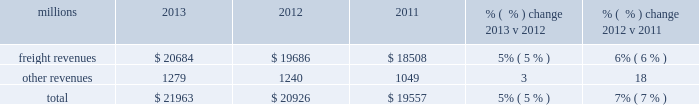F0b7 financial expectations 2013 we are cautious about the economic environment , but , assuming that industrial production grows approximately 3% ( 3 % ) as projected , volume should exceed 2013 levels .
Even with no volume growth , we expect earnings to exceed 2013 earnings , generated by core pricing gains , on-going network improvements and productivity initiatives .
We expect that free cash flow for 2014 will be lower than 2013 as higher cash from operations will be more than offset by additional cash of approximately $ 400 million that will be used to pay income taxes that were previously deferred through bonus depreciation , increased capital spend and higher dividend payments .
Results of operations operating revenues millions 2013 2012 2011 % (  % ) change 2013 v 2012 % (  % ) change 2012 v 2011 .
We generate freight revenues by transporting freight or other materials from our six commodity groups .
Freight revenues vary with volume ( carloads ) and arc .
Changes in price , traffic mix and fuel surcharges drive arc .
We provide some of our customers with contractual incentives for meeting or exceeding specified cumulative volumes or shipping to and from specific locations , which we record as reductions to freight revenues based on the actual or projected future shipments .
We recognize freight revenues as shipments move from origin to destination .
We allocate freight revenues between reporting periods based on the relative transit time in each reporting period and recognize expenses as we incur them .
Other revenues include revenues earned by our subsidiaries , revenues from our commuter rail operations , and accessorial revenues , which we earn when customers retain equipment owned or controlled by us or when we perform additional services such as switching or storage .
We recognize other revenues as we perform services or meet contractual obligations .
Freight revenues from five of our six commodity groups increased during 2013 compared to 2012 .
Revenue from agricultural products was down slightly compared to 2012 .
Arc increased 5% ( 5 % ) , driven by core pricing gains , shifts in business mix and an automotive logistics management arrangement .
Volume was essentially flat year over year as growth in automotives , frac sand , crude oil and domestic intermodal offset declines in coal , international intermodal and grain shipments .
Freight revenues from four of our six commodity groups increased during 2012 compared to 2011 .
Revenues from coal and agricultural products declined during the year .
Our franchise diversity allowed us to take advantage of growth from shale-related markets ( crude oil , frac sand and pipe ) and strong automotive manufacturing , which offset volume declines from coal and agricultural products .
Arc increased 7% ( 7 % ) , driven by core pricing gains and higher fuel cost recoveries .
Improved fuel recovery provisions and higher fuel prices , including the lag effect of our programs ( surcharges trail fluctuations in fuel price by approximately two months ) , combined to increase revenues from fuel surcharges .
Our fuel surcharge programs generated freight revenues of $ 2.6 billion , $ 2.6 billion , and $ 2.2 billion in 2013 , 2012 , and 2011 , respectively .
Fuel surcharge in 2013 was essentially flat versus 2012 as lower fuel price offset improved fuel recovery provisions and the lag effect of our programs ( surcharges trail fluctuations in fuel price by approximately two months ) .
Rising fuel prices and more shipments subject to fuel surcharges drove the increase from 2011 to 2012 .
In 2013 , other revenue increased from 2012 due primarily to miscellaneous contract revenue and higher revenues at our subsidiaries that broker intermodal and automotive services .
In 2012 , other revenues increased from 2011 due primarily to higher revenues at our subsidiaries that broker intermodal and automotive services .
Assessorial revenues also increased in 2012 due to container revenue related to an increase in intermodal shipments. .
In 2013 what was the percent of the operating revenues that was attributable to other revenues? 
Computations: (1279 / 21963)
Answer: 0.05823. F0b7 financial expectations 2013 we are cautious about the economic environment , but , assuming that industrial production grows approximately 3% ( 3 % ) as projected , volume should exceed 2013 levels .
Even with no volume growth , we expect earnings to exceed 2013 earnings , generated by core pricing gains , on-going network improvements and productivity initiatives .
We expect that free cash flow for 2014 will be lower than 2013 as higher cash from operations will be more than offset by additional cash of approximately $ 400 million that will be used to pay income taxes that were previously deferred through bonus depreciation , increased capital spend and higher dividend payments .
Results of operations operating revenues millions 2013 2012 2011 % (  % ) change 2013 v 2012 % (  % ) change 2012 v 2011 .
We generate freight revenues by transporting freight or other materials from our six commodity groups .
Freight revenues vary with volume ( carloads ) and arc .
Changes in price , traffic mix and fuel surcharges drive arc .
We provide some of our customers with contractual incentives for meeting or exceeding specified cumulative volumes or shipping to and from specific locations , which we record as reductions to freight revenues based on the actual or projected future shipments .
We recognize freight revenues as shipments move from origin to destination .
We allocate freight revenues between reporting periods based on the relative transit time in each reporting period and recognize expenses as we incur them .
Other revenues include revenues earned by our subsidiaries , revenues from our commuter rail operations , and accessorial revenues , which we earn when customers retain equipment owned or controlled by us or when we perform additional services such as switching or storage .
We recognize other revenues as we perform services or meet contractual obligations .
Freight revenues from five of our six commodity groups increased during 2013 compared to 2012 .
Revenue from agricultural products was down slightly compared to 2012 .
Arc increased 5% ( 5 % ) , driven by core pricing gains , shifts in business mix and an automotive logistics management arrangement .
Volume was essentially flat year over year as growth in automotives , frac sand , crude oil and domestic intermodal offset declines in coal , international intermodal and grain shipments .
Freight revenues from four of our six commodity groups increased during 2012 compared to 2011 .
Revenues from coal and agricultural products declined during the year .
Our franchise diversity allowed us to take advantage of growth from shale-related markets ( crude oil , frac sand and pipe ) and strong automotive manufacturing , which offset volume declines from coal and agricultural products .
Arc increased 7% ( 7 % ) , driven by core pricing gains and higher fuel cost recoveries .
Improved fuel recovery provisions and higher fuel prices , including the lag effect of our programs ( surcharges trail fluctuations in fuel price by approximately two months ) , combined to increase revenues from fuel surcharges .
Our fuel surcharge programs generated freight revenues of $ 2.6 billion , $ 2.6 billion , and $ 2.2 billion in 2013 , 2012 , and 2011 , respectively .
Fuel surcharge in 2013 was essentially flat versus 2012 as lower fuel price offset improved fuel recovery provisions and the lag effect of our programs ( surcharges trail fluctuations in fuel price by approximately two months ) .
Rising fuel prices and more shipments subject to fuel surcharges drove the increase from 2011 to 2012 .
In 2013 , other revenue increased from 2012 due primarily to miscellaneous contract revenue and higher revenues at our subsidiaries that broker intermodal and automotive services .
In 2012 , other revenues increased from 2011 due primarily to higher revenues at our subsidiaries that broker intermodal and automotive services .
Assessorial revenues also increased in 2012 due to container revenue related to an increase in intermodal shipments. .
What was the percentage change in fuel surcharge revenues from 2012 to 2013? 
Computations: ((2.6 - 2.6) / 2.6)
Answer: 0.0. 